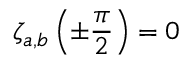<formula> <loc_0><loc_0><loc_500><loc_500>\zeta _ { a , b } \left ( \pm \frac { \pi } { 2 } \right ) = 0</formula> 